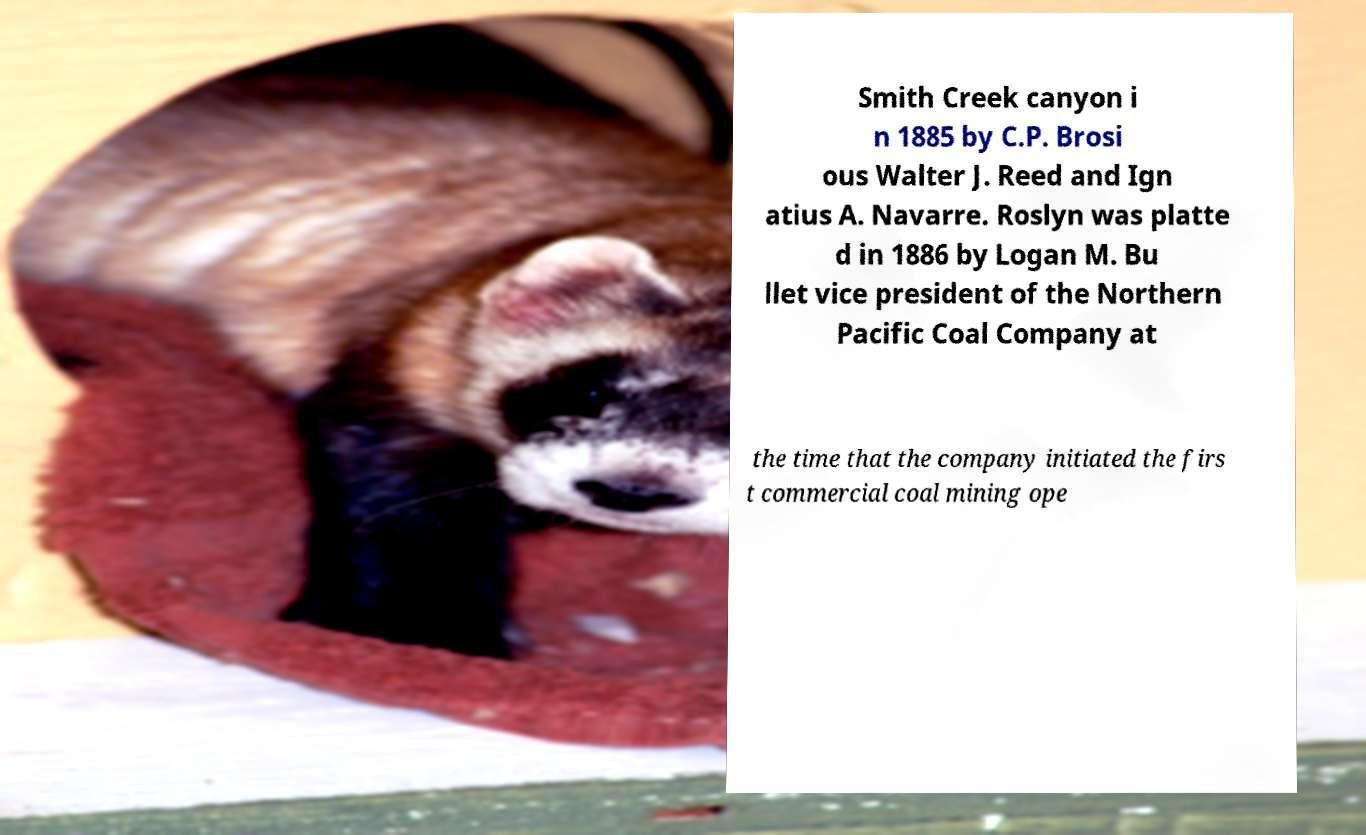Could you extract and type out the text from this image? Smith Creek canyon i n 1885 by C.P. Brosi ous Walter J. Reed and Ign atius A. Navarre. Roslyn was platte d in 1886 by Logan M. Bu llet vice president of the Northern Pacific Coal Company at the time that the company initiated the firs t commercial coal mining ope 